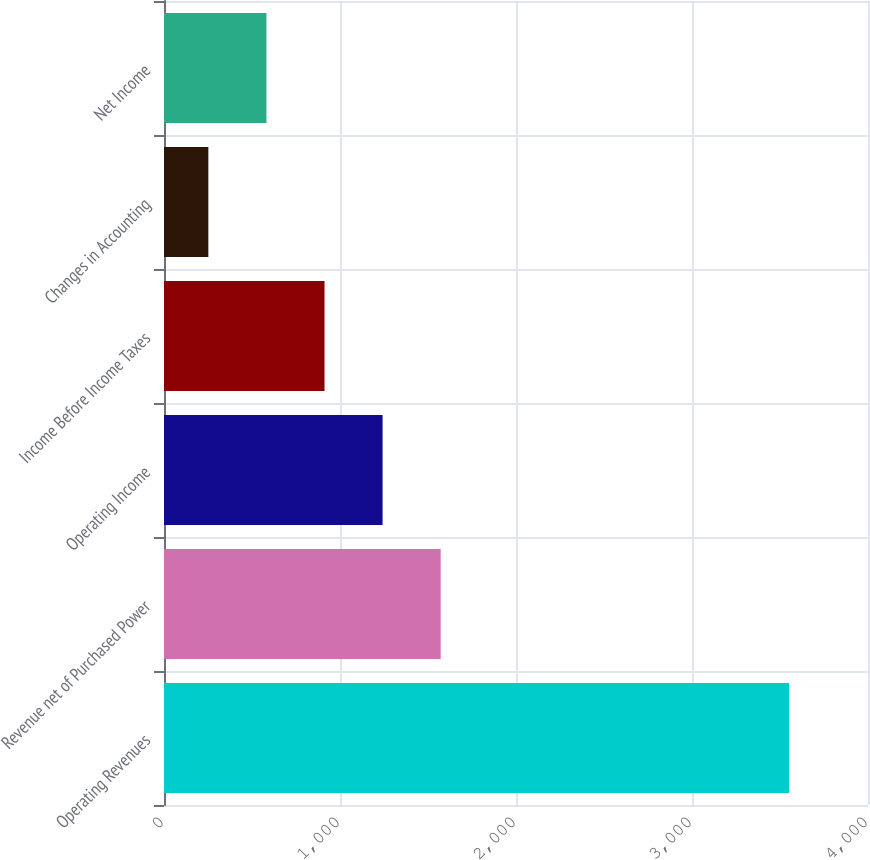<chart> <loc_0><loc_0><loc_500><loc_500><bar_chart><fcel>Operating Revenues<fcel>Revenue net of Purchased Power<fcel>Operating Income<fcel>Income Before Income Taxes<fcel>Changes in Accounting<fcel>Net Income<nl><fcel>3552<fcel>1572<fcel>1242<fcel>912<fcel>252<fcel>582<nl></chart> 